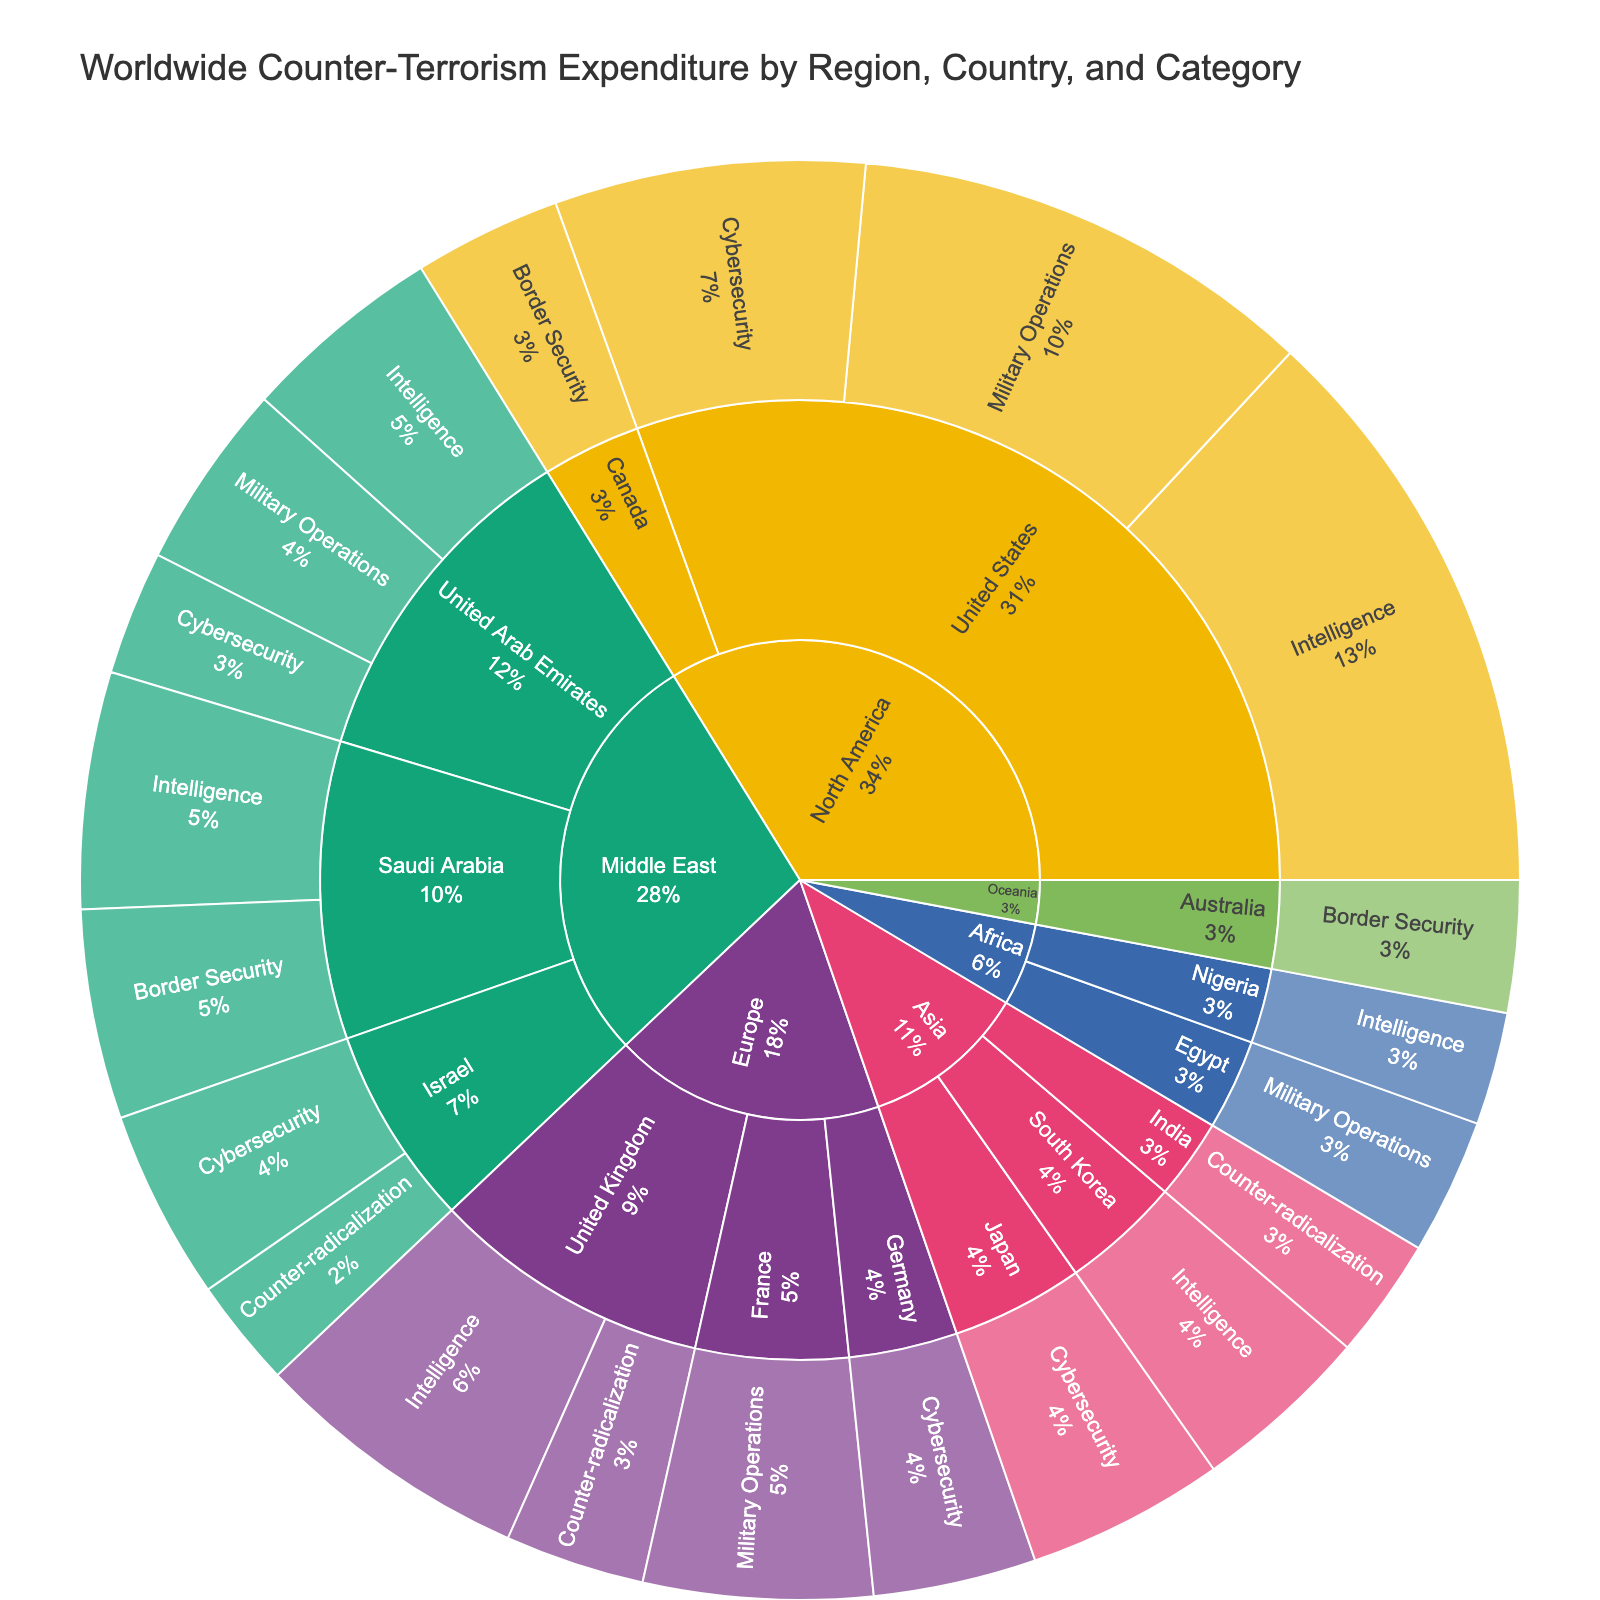What is the total counter-terrorism expenditure of the United Arab Emirates? To find the total expenditure, sum the values of all categories for the United Arab Emirates: Intelligence (5200) + Military Operations (4800) + Cybersecurity (3200). The sum is 5200 + 4800 + 3200 = 13200 million dollars.
Answer: 13200 million dollars Which country has the highest expenditure on Intelligence? To determine this, look at the Intelligence expenditures of each country: United States (15000), United Kingdom (7200), Saudi Arabia (6100), United Arab Emirates (5200), South Korea (4600), Nigeria (2900). The United States has the highest expenditure with 15000 million dollars.
Answer: United States How much more does the United States spend on Cybersecurity compared to Israel? The United States spends 8000 million dollars on Cybersecurity, and Israel spends 4900 million dollars. The difference is 8000 - 4900 = 3100 million dollars.
Answer: 3100 million dollars Among the countries in Europe, which category has the lowest expenditure, and which country corresponds to it? The European countries have the following expenditures: United Kingdom (Intelligence: 7200, Counter-radicalization: 3600), France (Military Operations: 5900), Germany (Cybersecurity: 4200). The lowest expenditure is Counter-radicalization with 3600 million dollars in the United Kingdom.
Answer: Counter-radicalization, United Kingdom What proportion of the total worldwide expenditure is contributed by the Middle East region? Sum the total expenditures of all Middle East countries: UAE (5200 + 4800 + 3200), Saudi Arabia (6100 + 5400), Israel (4900 + 2800). The sum is 13200 (UAE) + 11500 (Saudi Arabia) + 7700 (Israel) = 32400 million dollars. Next, sum the total worldwide expenditure: 32400 (Middle East) + 7200 + 3600 + 5900 + 4200 (Europe) + 15000 + 12000 + 8000 + 3800 (North America) + 5100 + 4600 + 3100 (Asia) + 3500 + 2900 (Africa) + 3400 (Oceania). The total is 103100 million dollars. The proportion is 32400 / 103100 ≈ 0.3145 or 31.45%.
Answer: 31.45% What is the difference in expenditure on Military Operations between the United States and the United Arab Emirates? The United States spends 12000 million dollars on Military Operations, while the United Arab Emirates spends 4800 million dollars. The difference is 12000 - 4800 = 7200 million dollars.
Answer: 7200 million dollars Which categories are funded by Saudi Arabia, and what are their respective expenditures? Saudi Arabia funds Intelligence and Border Security. The expenditures are Intelligence: 6100 million dollars, and Border Security: 5400 million dollars.
Answer: Intelligence: 6100 million dollars, Border Security: 5400 million dollars Which country in North America has the lowest expenditure in any category, and what is the amount? The countries in North America and their expenditures are: United States (Intelligence: 15000, Military Operations: 12000, Cybersecurity: 8000), and Canada (Border Security: 3800). The lowest expenditure is by Canada with 3800 million dollars on Border Security.
Answer: Canada, 3800 million dollars 